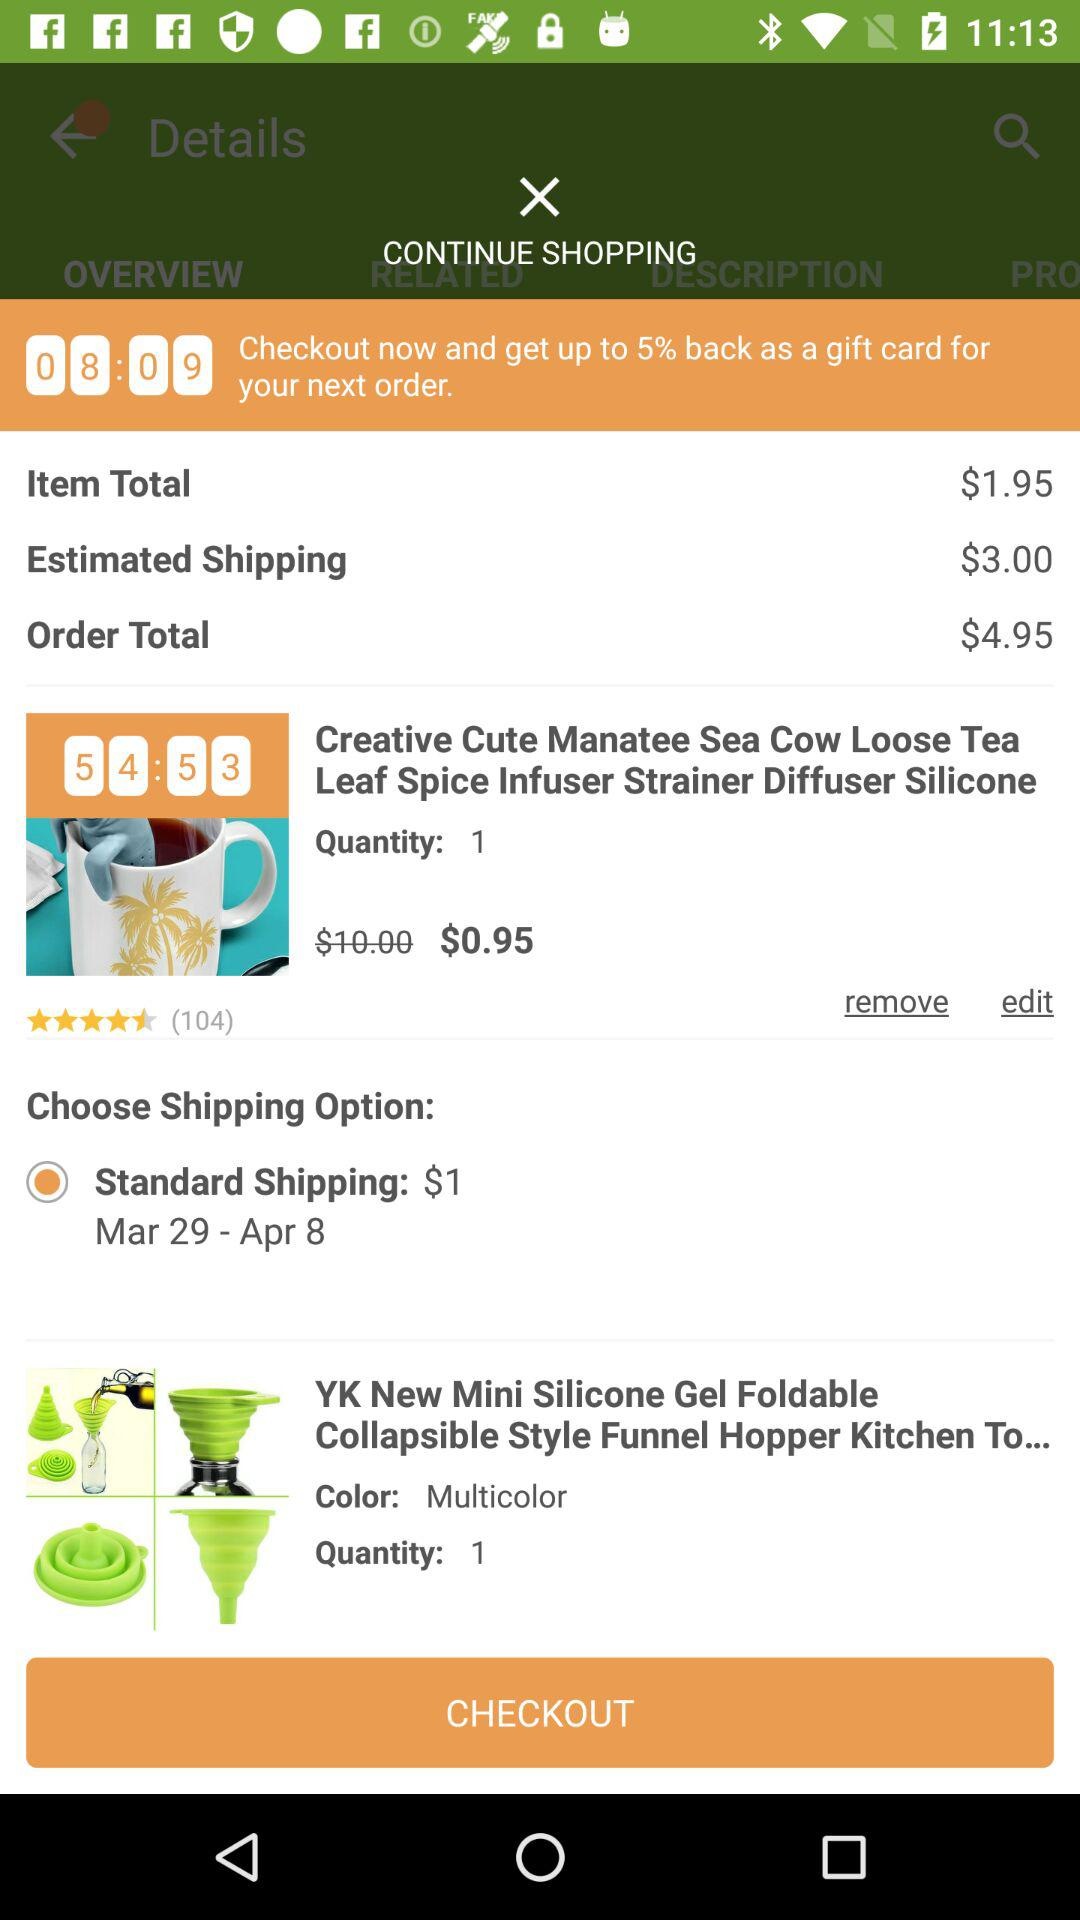How many items are in the cart?
Answer the question using a single word or phrase. 2 